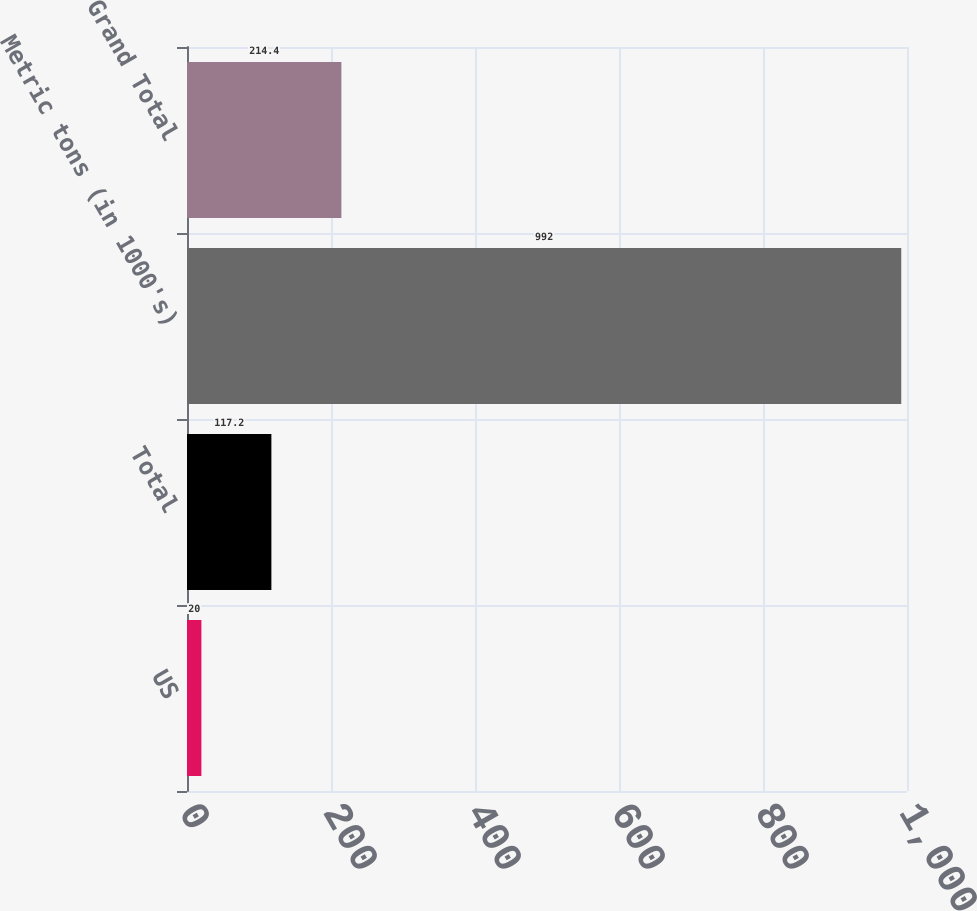<chart> <loc_0><loc_0><loc_500><loc_500><bar_chart><fcel>US<fcel>Total<fcel>Metric tons (in 1000's)<fcel>Grand Total<nl><fcel>20<fcel>117.2<fcel>992<fcel>214.4<nl></chart> 